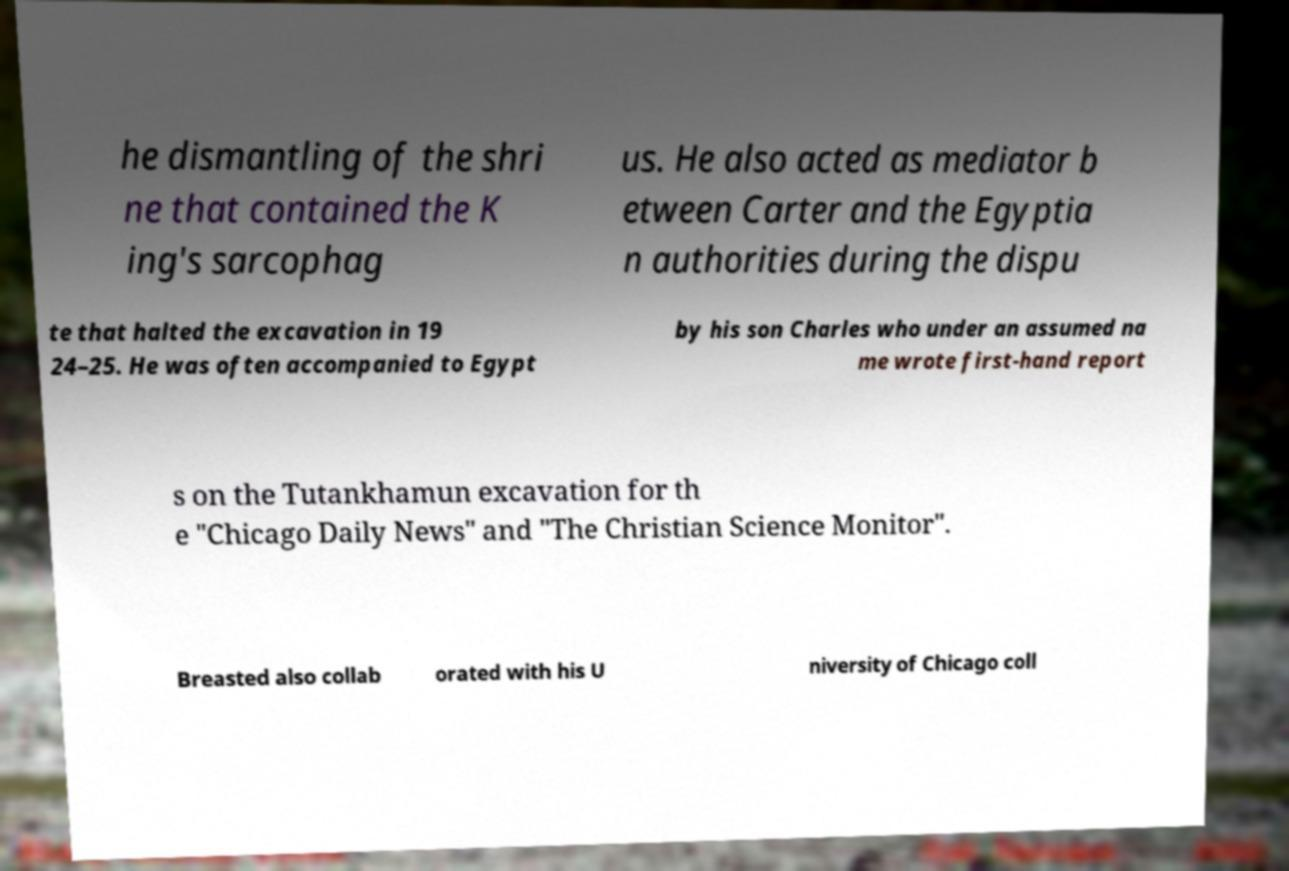Can you read and provide the text displayed in the image?This photo seems to have some interesting text. Can you extract and type it out for me? he dismantling of the shri ne that contained the K ing's sarcophag us. He also acted as mediator b etween Carter and the Egyptia n authorities during the dispu te that halted the excavation in 19 24–25. He was often accompanied to Egypt by his son Charles who under an assumed na me wrote first-hand report s on the Tutankhamun excavation for th e "Chicago Daily News" and "The Christian Science Monitor". Breasted also collab orated with his U niversity of Chicago coll 